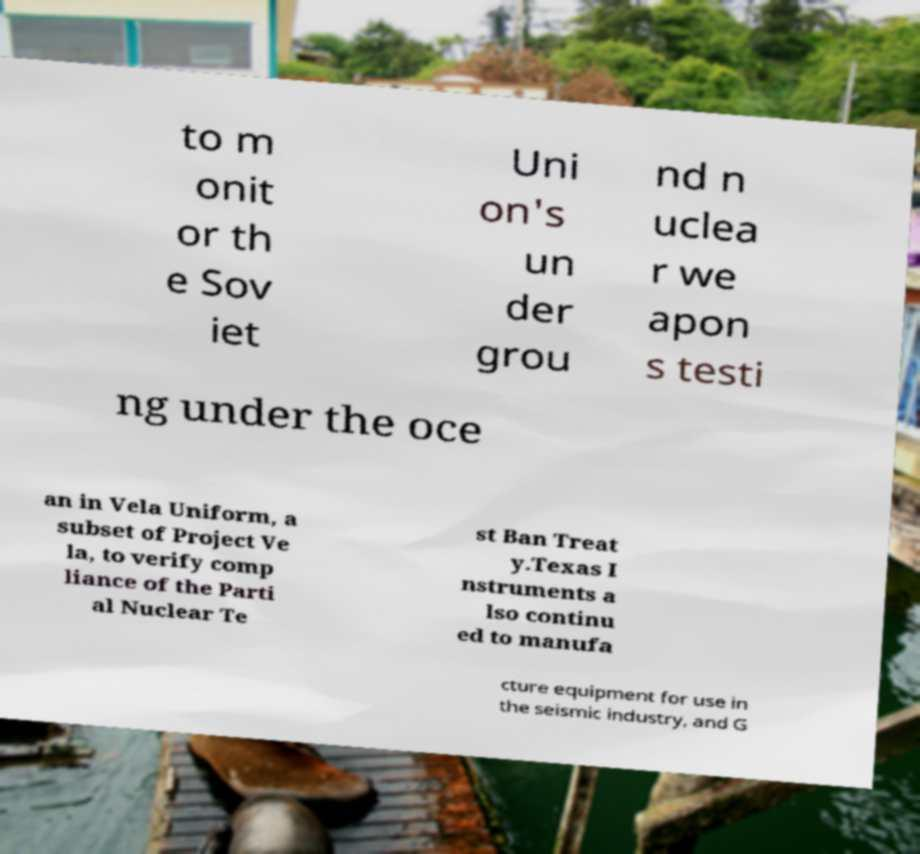For documentation purposes, I need the text within this image transcribed. Could you provide that? to m onit or th e Sov iet Uni on's un der grou nd n uclea r we apon s testi ng under the oce an in Vela Uniform, a subset of Project Ve la, to verify comp liance of the Parti al Nuclear Te st Ban Treat y.Texas I nstruments a lso continu ed to manufa cture equipment for use in the seismic industry, and G 